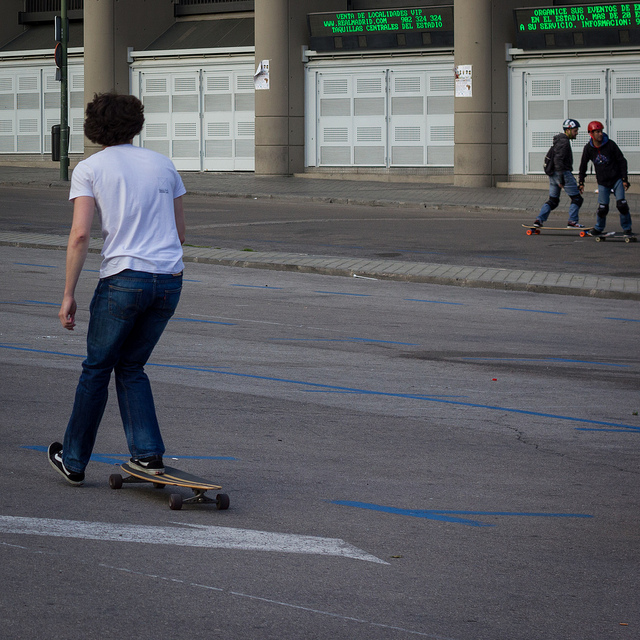<image>What is the racial background of the kid in the foreground? I am not sure what the racial background of the kid in the foreground is. It can be caucasian or white. What is the racial background of the kid in the foreground? I don't know the racial background of the kid in the foreground. It can be either caucasian or white. 